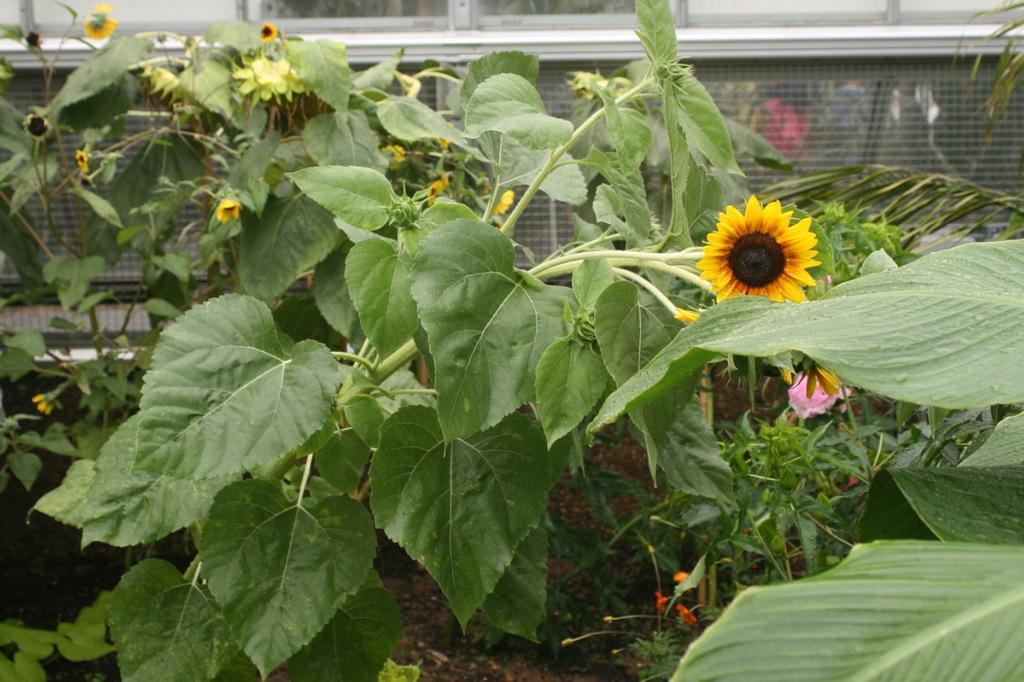What type of plants can be seen in the front of the image? There are flower plants in the front of the image. What can be seen in the background of the image? There is a mesh and windows in the background of the image. Can you describe the people visible through the mesh? Unfortunately, the facts provided do not give any information about the people visible through the mesh. What might be the purpose of the mesh in the background? The mesh could be serving as a barrier or decorative element in the background. What type of destruction can be seen in the image? There is no destruction present in the image; it features flower plants, a mesh, and windows. Are there any bears visible in the image? There are no bears present in the image. 